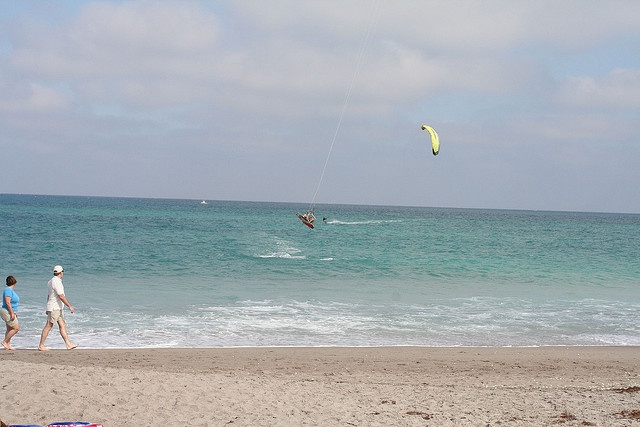Describe the objects in this image and their specific colors. I can see people in lightblue, lightgray, darkgray, and tan tones, people in lightblue, darkgray, tan, and gray tones, kite in lightblue, khaki, darkgray, beige, and tan tones, surfboard in lightblue, gray, maroon, black, and darkgray tones, and people in lightblue, gray, black, darkgray, and purple tones in this image. 